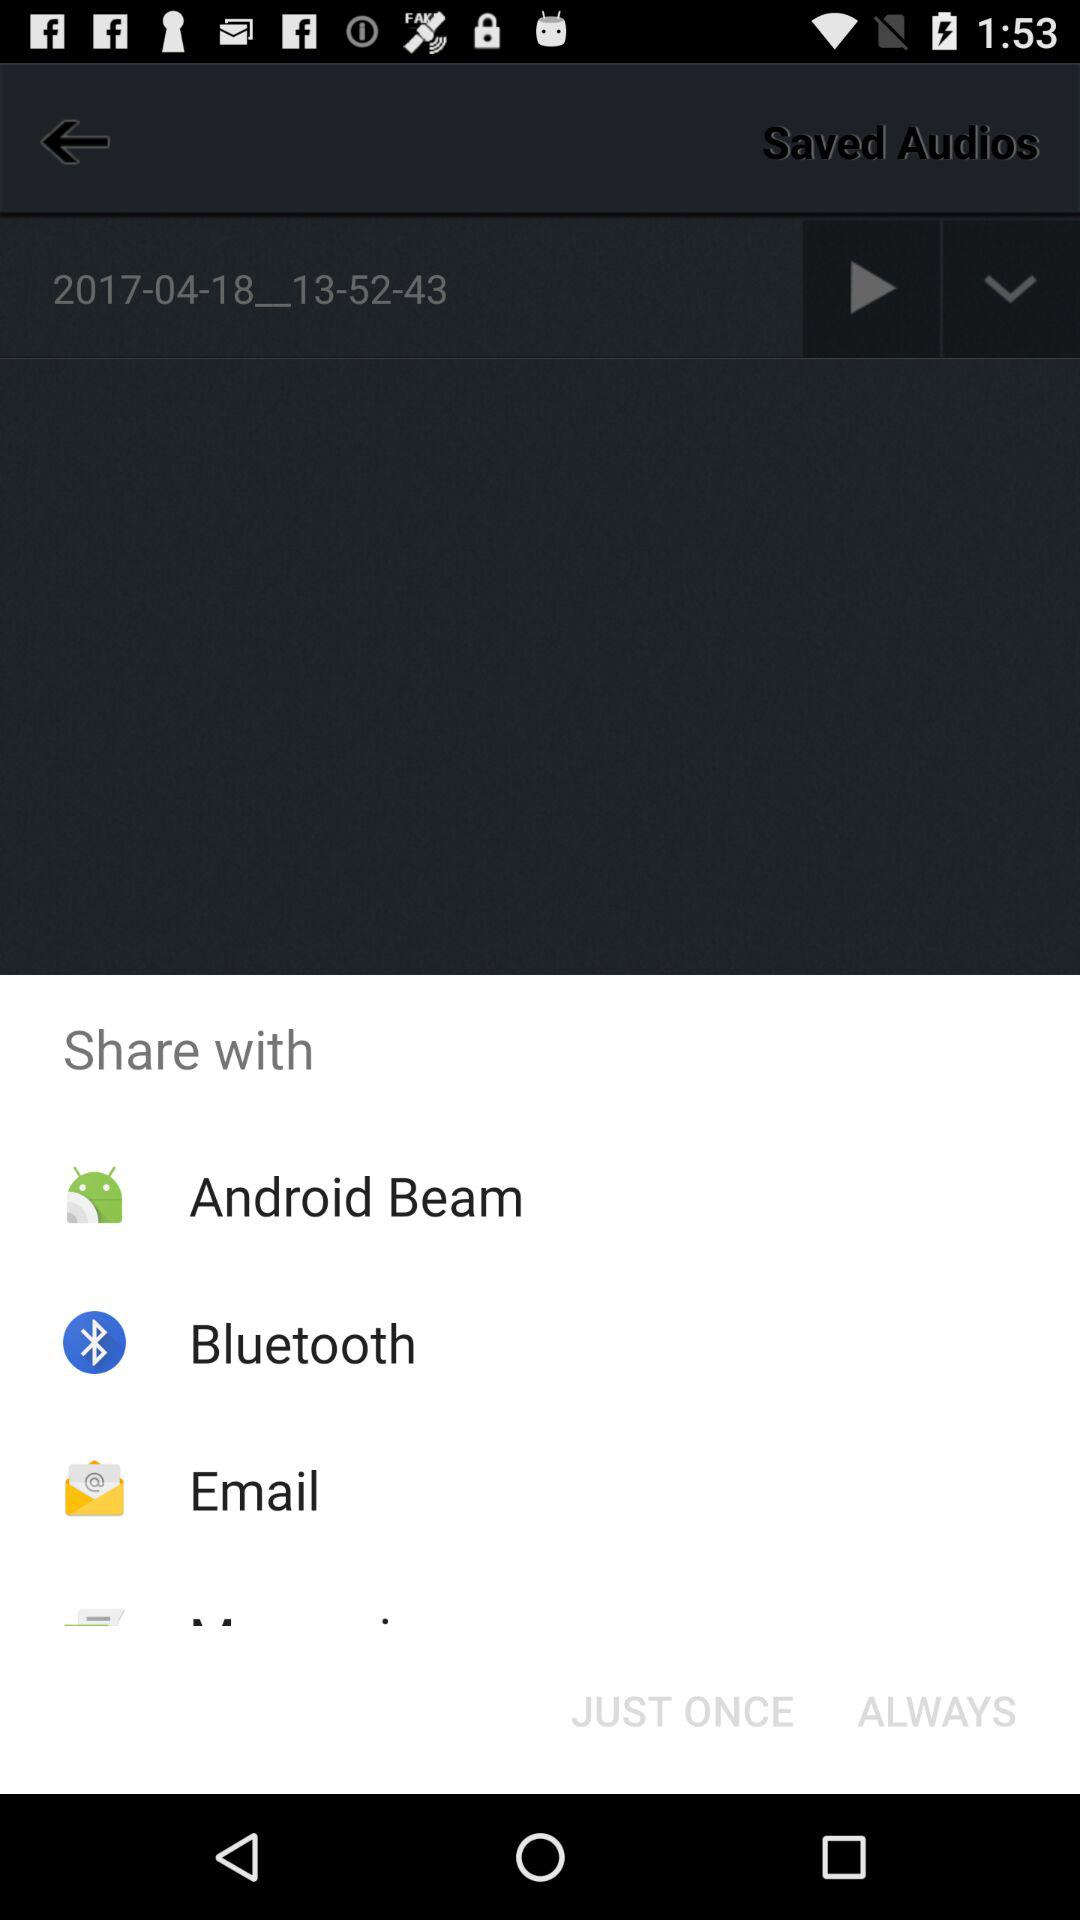How many share options are there?
Answer the question using a single word or phrase. 4 